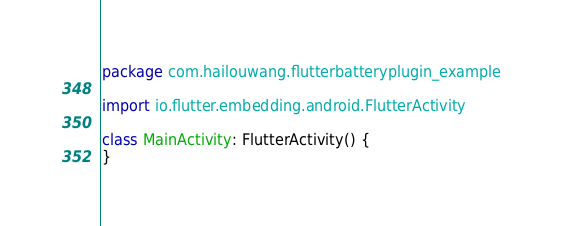Convert code to text. <code><loc_0><loc_0><loc_500><loc_500><_Kotlin_>package com.hailouwang.flutterbatteryplugin_example

import io.flutter.embedding.android.FlutterActivity

class MainActivity: FlutterActivity() {
}
</code> 